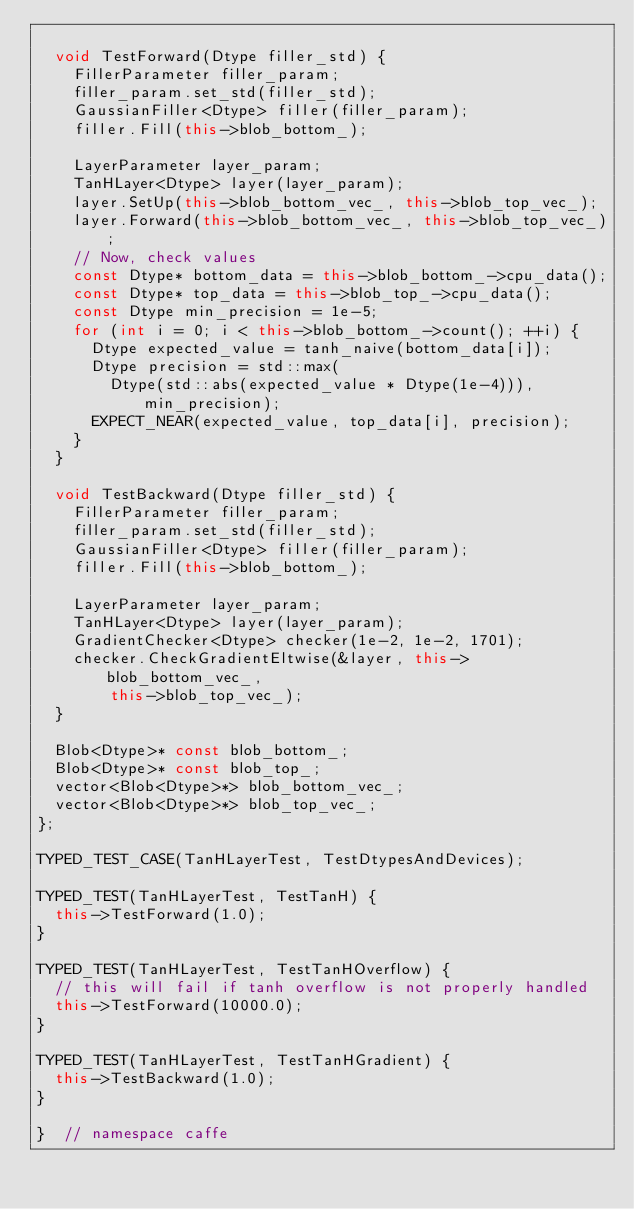Convert code to text. <code><loc_0><loc_0><loc_500><loc_500><_C++_>
  void TestForward(Dtype filler_std) {
    FillerParameter filler_param;
    filler_param.set_std(filler_std);
    GaussianFiller<Dtype> filler(filler_param);
    filler.Fill(this->blob_bottom_);

    LayerParameter layer_param;
    TanHLayer<Dtype> layer(layer_param);
    layer.SetUp(this->blob_bottom_vec_, this->blob_top_vec_);
    layer.Forward(this->blob_bottom_vec_, this->blob_top_vec_);
    // Now, check values
    const Dtype* bottom_data = this->blob_bottom_->cpu_data();
    const Dtype* top_data = this->blob_top_->cpu_data();
    const Dtype min_precision = 1e-5;
    for (int i = 0; i < this->blob_bottom_->count(); ++i) {
      Dtype expected_value = tanh_naive(bottom_data[i]);
      Dtype precision = std::max(
        Dtype(std::abs(expected_value * Dtype(1e-4))), min_precision);
      EXPECT_NEAR(expected_value, top_data[i], precision);
    }
  }

  void TestBackward(Dtype filler_std) {
    FillerParameter filler_param;
    filler_param.set_std(filler_std);
    GaussianFiller<Dtype> filler(filler_param);
    filler.Fill(this->blob_bottom_);

    LayerParameter layer_param;
    TanHLayer<Dtype> layer(layer_param);
    GradientChecker<Dtype> checker(1e-2, 1e-2, 1701);
    checker.CheckGradientEltwise(&layer, this->blob_bottom_vec_,
        this->blob_top_vec_);
  }

  Blob<Dtype>* const blob_bottom_;
  Blob<Dtype>* const blob_top_;
  vector<Blob<Dtype>*> blob_bottom_vec_;
  vector<Blob<Dtype>*> blob_top_vec_;
};

TYPED_TEST_CASE(TanHLayerTest, TestDtypesAndDevices);

TYPED_TEST(TanHLayerTest, TestTanH) {
  this->TestForward(1.0);
}

TYPED_TEST(TanHLayerTest, TestTanHOverflow) {
  // this will fail if tanh overflow is not properly handled
  this->TestForward(10000.0);
}

TYPED_TEST(TanHLayerTest, TestTanHGradient) {
  this->TestBackward(1.0);
}

}  // namespace caffe
</code> 